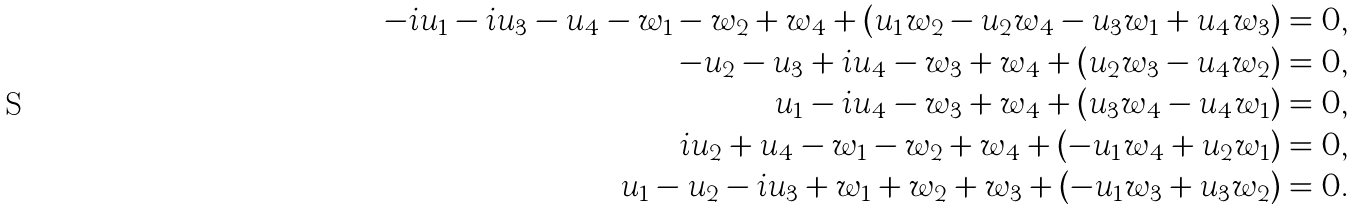<formula> <loc_0><loc_0><loc_500><loc_500>- i u _ { 1 } - i u _ { 3 } - u _ { 4 } - w _ { 1 } - w _ { 2 } + w _ { 4 } + ( u _ { 1 } w _ { 2 } - u _ { 2 } w _ { 4 } - u _ { 3 } w _ { 1 } + u _ { 4 } w _ { 3 } ) & = 0 , \\ - u _ { 2 } - u _ { 3 } + i u _ { 4 } - w _ { 3 } + w _ { 4 } + ( u _ { 2 } w _ { 3 } - u _ { 4 } w _ { 2 } ) & = 0 , \\ u _ { 1 } - i u _ { 4 } - w _ { 3 } + w _ { 4 } + ( u _ { 3 } w _ { 4 } - u _ { 4 } w _ { 1 } ) & = 0 , \\ i u _ { 2 } + u _ { 4 } - w _ { 1 } - w _ { 2 } + w _ { 4 } + ( - u _ { 1 } w _ { 4 } + u _ { 2 } w _ { 1 } ) & = 0 , \\ u _ { 1 } - u _ { 2 } - i u _ { 3 } + w _ { 1 } + w _ { 2 } + w _ { 3 } + ( - u _ { 1 } w _ { 3 } + u _ { 3 } w _ { 2 } ) & = 0 . \\</formula> 